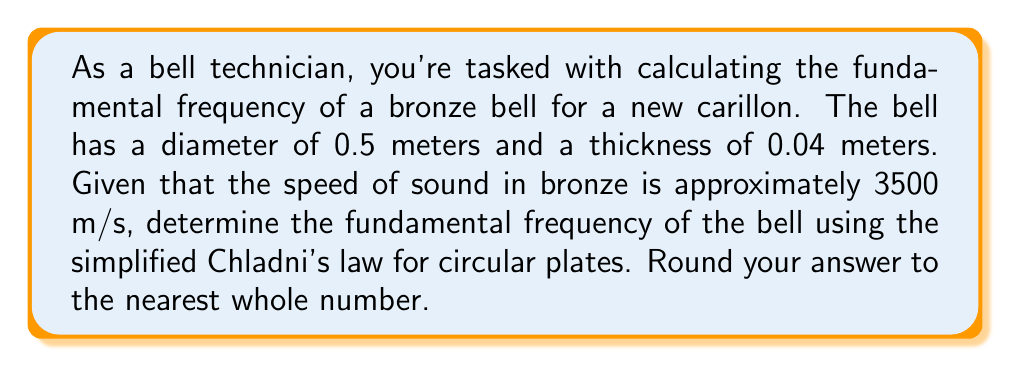Can you solve this math problem? To solve this problem, we'll use Chladni's law for circular plates, which relates the fundamental frequency of a circular plate to its physical properties. The simplified version of this law for a bell can be expressed as:

$$f = \frac{0.5}{d}\sqrt{\frac{E}{\rho}}$$

Where:
$f$ is the fundamental frequency in Hz
$d$ is the diameter of the bell in meters
$E$ is Young's modulus of the material
$\rho$ is the density of the material

For bells, we can approximate this further using the speed of sound in the material:

$$f \approx \frac{0.5c}{d}$$

Where:
$c$ is the speed of sound in the material
$d$ is the diameter of the bell

Given:
- Diameter of the bell, $d = 0.5$ m
- Speed of sound in bronze, $c = 3500$ m/s

Let's substitute these values into our equation:

$$f \approx \frac{0.5 \cdot 3500}{0.5}$$

$$f \approx 3500 \text{ Hz}$$

Rounding to the nearest whole number:

$$f \approx 3500 \text{ Hz}$$

Note that this is an approximation, and the actual frequency may vary slightly due to factors such as the bell's shape, thickness variations, and exact composition of the bronze alloy.
Answer: $3500 \text{ Hz}$ 